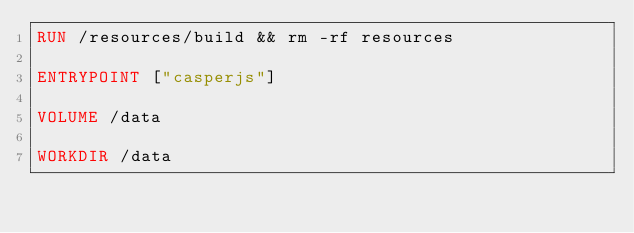<code> <loc_0><loc_0><loc_500><loc_500><_Dockerfile_>RUN /resources/build && rm -rf resources

ENTRYPOINT ["casperjs"]

VOLUME /data

WORKDIR /data
</code> 